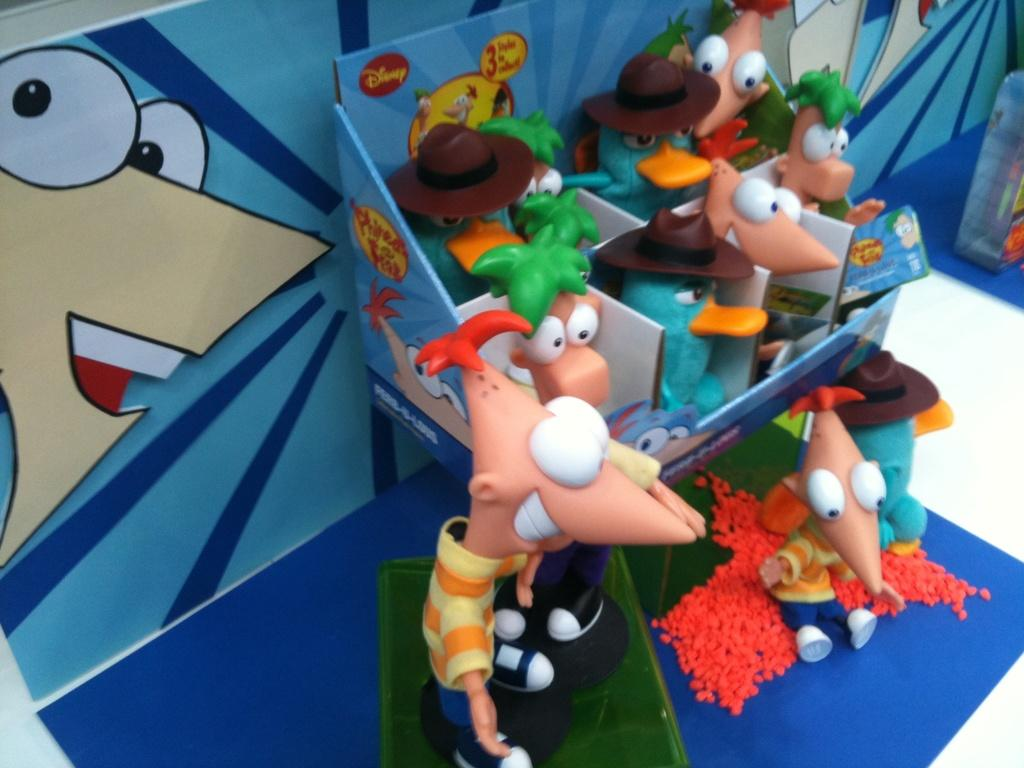What type of objects can be seen in the image? There are toys in the image. What can be seen on the ground in the image? The ground is visible in the image with some objects. What is on the wall in the image? There is a wall in the image with a poster. How many sheep are visible in the image? There are no sheep present in the image. What type of rail is attached to the wall in the image? There is no rail present in the image; only toys, the ground, and a wall with a poster are visible. 